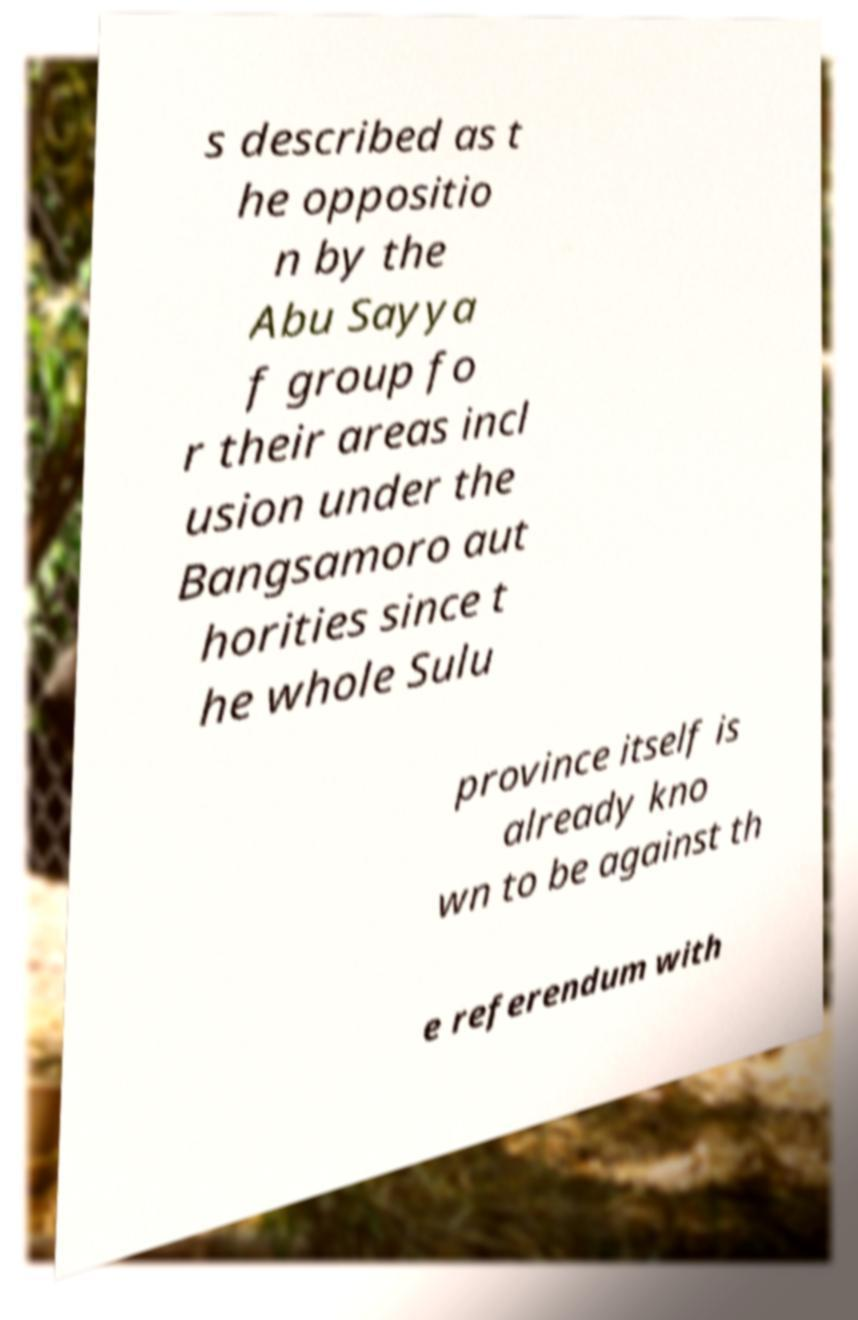Please identify and transcribe the text found in this image. s described as t he oppositio n by the Abu Sayya f group fo r their areas incl usion under the Bangsamoro aut horities since t he whole Sulu province itself is already kno wn to be against th e referendum with 